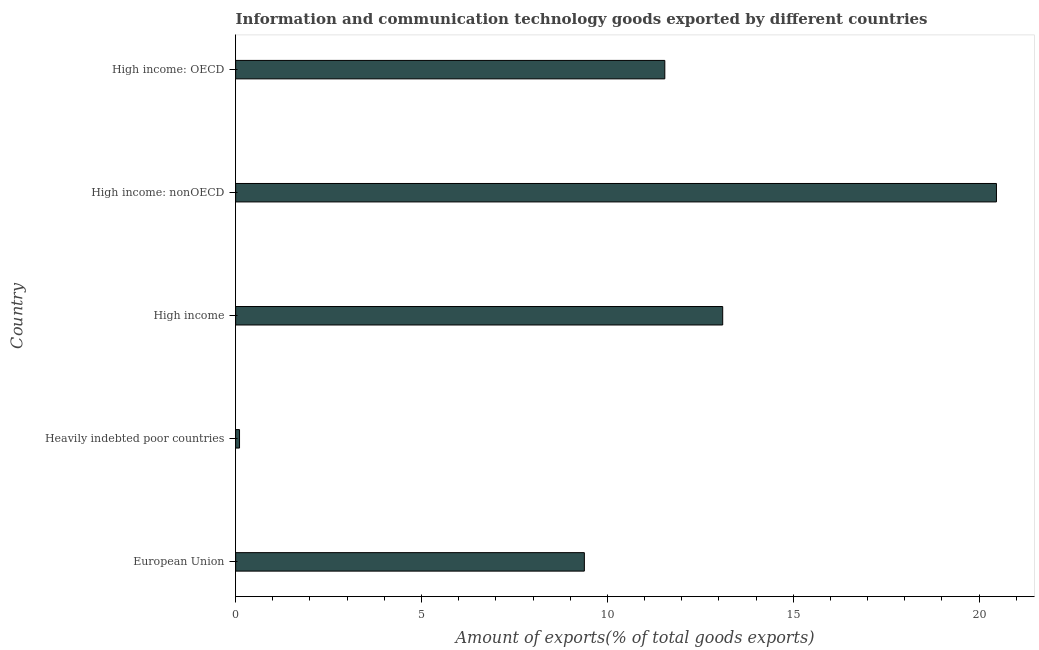Does the graph contain grids?
Offer a terse response. No. What is the title of the graph?
Your answer should be very brief. Information and communication technology goods exported by different countries. What is the label or title of the X-axis?
Make the answer very short. Amount of exports(% of total goods exports). What is the label or title of the Y-axis?
Your response must be concise. Country. What is the amount of ict goods exports in High income: OECD?
Your response must be concise. 11.55. Across all countries, what is the maximum amount of ict goods exports?
Keep it short and to the point. 20.47. Across all countries, what is the minimum amount of ict goods exports?
Provide a short and direct response. 0.11. In which country was the amount of ict goods exports maximum?
Provide a short and direct response. High income: nonOECD. In which country was the amount of ict goods exports minimum?
Provide a succinct answer. Heavily indebted poor countries. What is the sum of the amount of ict goods exports?
Your answer should be very brief. 54.6. What is the difference between the amount of ict goods exports in European Union and High income?
Your answer should be compact. -3.72. What is the average amount of ict goods exports per country?
Your response must be concise. 10.92. What is the median amount of ict goods exports?
Provide a succinct answer. 11.55. In how many countries, is the amount of ict goods exports greater than 6 %?
Offer a very short reply. 4. What is the ratio of the amount of ict goods exports in European Union to that in High income: nonOECD?
Give a very brief answer. 0.46. Is the amount of ict goods exports in European Union less than that in Heavily indebted poor countries?
Your response must be concise. No. Is the difference between the amount of ict goods exports in Heavily indebted poor countries and High income: OECD greater than the difference between any two countries?
Offer a terse response. No. What is the difference between the highest and the second highest amount of ict goods exports?
Your answer should be very brief. 7.36. Is the sum of the amount of ict goods exports in High income and High income: OECD greater than the maximum amount of ict goods exports across all countries?
Give a very brief answer. Yes. What is the difference between the highest and the lowest amount of ict goods exports?
Ensure brevity in your answer.  20.36. How many countries are there in the graph?
Keep it short and to the point. 5. What is the difference between two consecutive major ticks on the X-axis?
Ensure brevity in your answer.  5. What is the Amount of exports(% of total goods exports) of European Union?
Provide a short and direct response. 9.38. What is the Amount of exports(% of total goods exports) in Heavily indebted poor countries?
Offer a terse response. 0.11. What is the Amount of exports(% of total goods exports) of High income?
Your response must be concise. 13.1. What is the Amount of exports(% of total goods exports) of High income: nonOECD?
Offer a terse response. 20.47. What is the Amount of exports(% of total goods exports) in High income: OECD?
Offer a terse response. 11.55. What is the difference between the Amount of exports(% of total goods exports) in European Union and Heavily indebted poor countries?
Provide a succinct answer. 9.28. What is the difference between the Amount of exports(% of total goods exports) in European Union and High income?
Offer a very short reply. -3.72. What is the difference between the Amount of exports(% of total goods exports) in European Union and High income: nonOECD?
Offer a very short reply. -11.09. What is the difference between the Amount of exports(% of total goods exports) in European Union and High income: OECD?
Provide a succinct answer. -2.16. What is the difference between the Amount of exports(% of total goods exports) in Heavily indebted poor countries and High income?
Your answer should be compact. -13. What is the difference between the Amount of exports(% of total goods exports) in Heavily indebted poor countries and High income: nonOECD?
Give a very brief answer. -20.36. What is the difference between the Amount of exports(% of total goods exports) in Heavily indebted poor countries and High income: OECD?
Ensure brevity in your answer.  -11.44. What is the difference between the Amount of exports(% of total goods exports) in High income and High income: nonOECD?
Your answer should be compact. -7.36. What is the difference between the Amount of exports(% of total goods exports) in High income and High income: OECD?
Provide a succinct answer. 1.56. What is the difference between the Amount of exports(% of total goods exports) in High income: nonOECD and High income: OECD?
Provide a short and direct response. 8.92. What is the ratio of the Amount of exports(% of total goods exports) in European Union to that in Heavily indebted poor countries?
Keep it short and to the point. 89.25. What is the ratio of the Amount of exports(% of total goods exports) in European Union to that in High income?
Offer a very short reply. 0.72. What is the ratio of the Amount of exports(% of total goods exports) in European Union to that in High income: nonOECD?
Ensure brevity in your answer.  0.46. What is the ratio of the Amount of exports(% of total goods exports) in European Union to that in High income: OECD?
Your answer should be compact. 0.81. What is the ratio of the Amount of exports(% of total goods exports) in Heavily indebted poor countries to that in High income?
Offer a terse response. 0.01. What is the ratio of the Amount of exports(% of total goods exports) in Heavily indebted poor countries to that in High income: nonOECD?
Provide a short and direct response. 0.01. What is the ratio of the Amount of exports(% of total goods exports) in Heavily indebted poor countries to that in High income: OECD?
Keep it short and to the point. 0.01. What is the ratio of the Amount of exports(% of total goods exports) in High income to that in High income: nonOECD?
Your answer should be compact. 0.64. What is the ratio of the Amount of exports(% of total goods exports) in High income to that in High income: OECD?
Your answer should be compact. 1.14. What is the ratio of the Amount of exports(% of total goods exports) in High income: nonOECD to that in High income: OECD?
Your answer should be very brief. 1.77. 